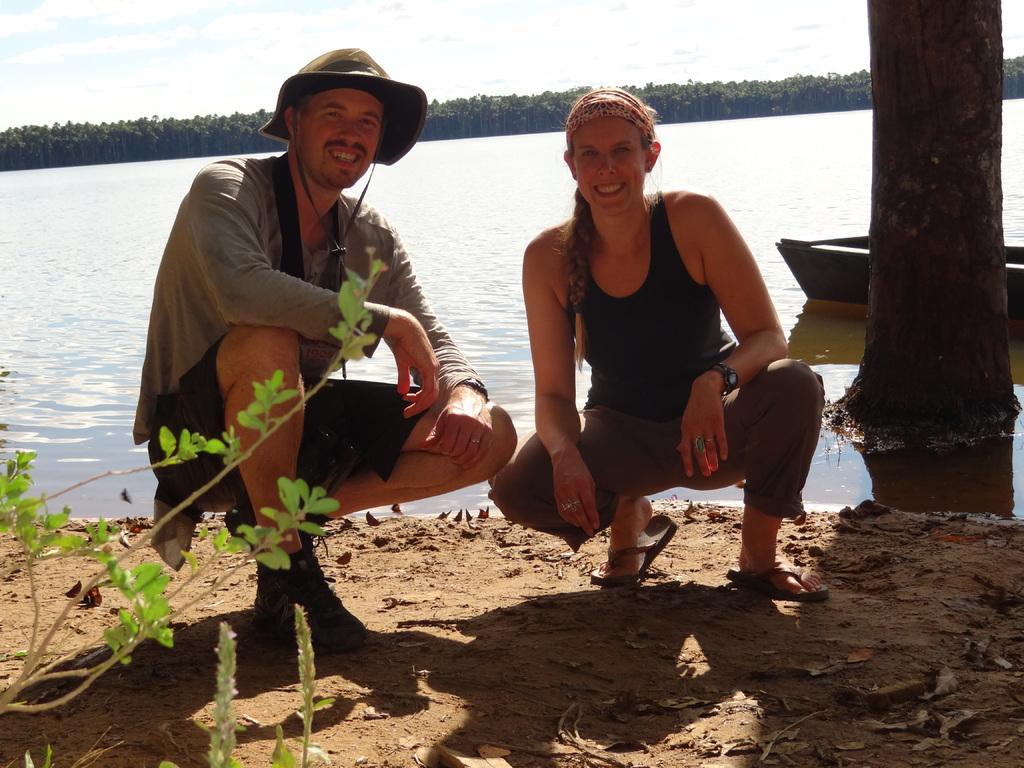Describe this image in one or two sentences. In this image we can see a man and a woman in crouch position on the ground and there is a plant and leaves on the ground. In the background we can see a boat on the water and there is a tree trunk on the right side and there are trees and clouds in the sky. 